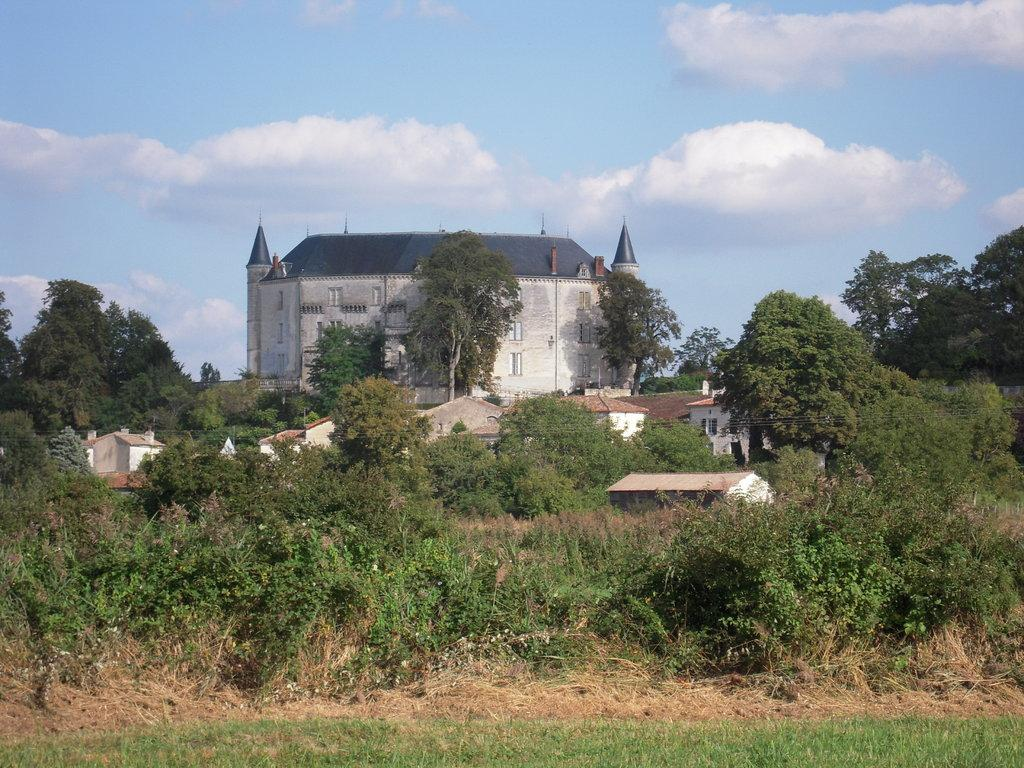What type of natural environment is depicted in the image? There are many trees and plants in the image, indicating a natural environment. What type of structures can be seen in the front of the image? There are small houses and a building in the front of the image. What is visible in the sky at the top of the image? There are clouds in the sky at the top of the image. What type of ground is visible at the bottom of the image? There is green grass at the bottom of the image. What type of power source is used to operate the train in the image? There is no train present in the image, so it is not possible to determine the type of power source used. 